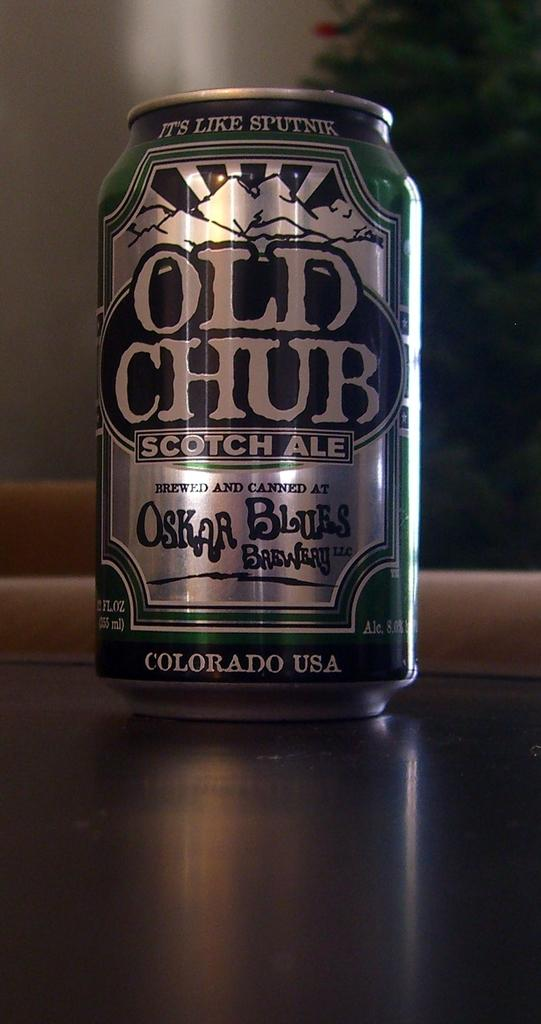Provide a one-sentence caption for the provided image. A can of Old Chub scotch ale sitting on a wooden table. 